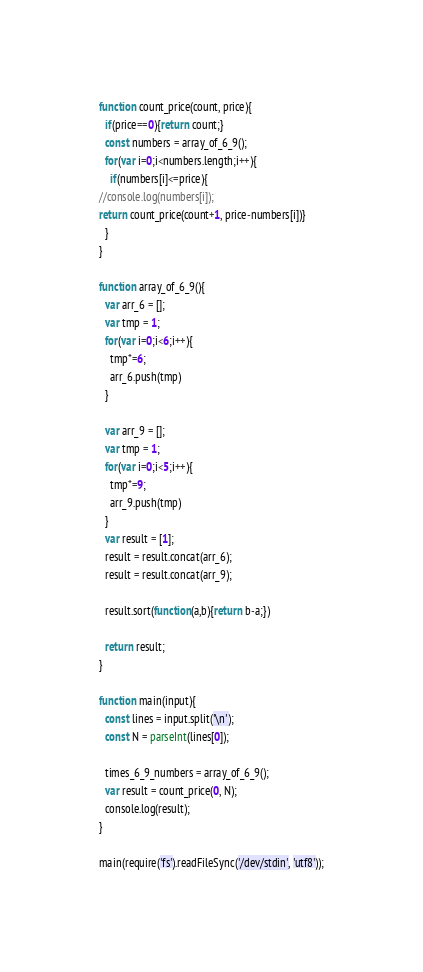<code> <loc_0><loc_0><loc_500><loc_500><_JavaScript_>function count_price(count, price){
  if(price==0){return count;}
  const numbers = array_of_6_9();
  for(var i=0;i<numbers.length;i++){
    if(numbers[i]<=price){
//console.log(numbers[i]);
return count_price(count+1, price-numbers[i])}
  }
}

function array_of_6_9(){
  var arr_6 = [];
  var tmp = 1;
  for(var i=0;i<6;i++){
    tmp*=6;
    arr_6.push(tmp)
  }

  var arr_9 = [];
  var tmp = 1;
  for(var i=0;i<5;i++){
    tmp*=9;
    arr_9.push(tmp)
  }
  var result = [1];
  result = result.concat(arr_6);
  result = result.concat(arr_9);

  result.sort(function(a,b){return b-a;})

  return result;
}

function main(input){
  const lines = input.split('\n');
  const N = parseInt(lines[0]);

  times_6_9_numbers = array_of_6_9();
  var result = count_price(0, N);
  console.log(result);
}

main(require('fs').readFileSync('/dev/stdin', 'utf8'));
</code> 